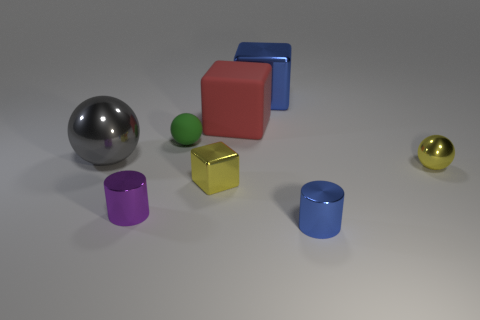Is there another yellow rubber thing that has the same shape as the tiny rubber thing?
Your answer should be very brief. No. Are the tiny ball behind the big gray metal thing and the small ball that is in front of the big sphere made of the same material?
Ensure brevity in your answer.  No. What shape is the object that is the same color as the small metallic cube?
Your answer should be compact. Sphere. How many green cylinders have the same material as the gray ball?
Your response must be concise. 0. What is the color of the big shiny block?
Ensure brevity in your answer.  Blue. Does the large object that is left of the green rubber ball have the same shape as the small yellow thing that is left of the yellow metallic ball?
Make the answer very short. No. There is a big shiny thing that is on the left side of the big shiny cube; what is its color?
Make the answer very short. Gray. Is the number of yellow blocks on the right side of the small blue cylinder less than the number of large blue metal things that are in front of the big red thing?
Provide a short and direct response. No. What number of other things are made of the same material as the small block?
Your answer should be compact. 5. Is the purple object made of the same material as the red block?
Give a very brief answer. No. 